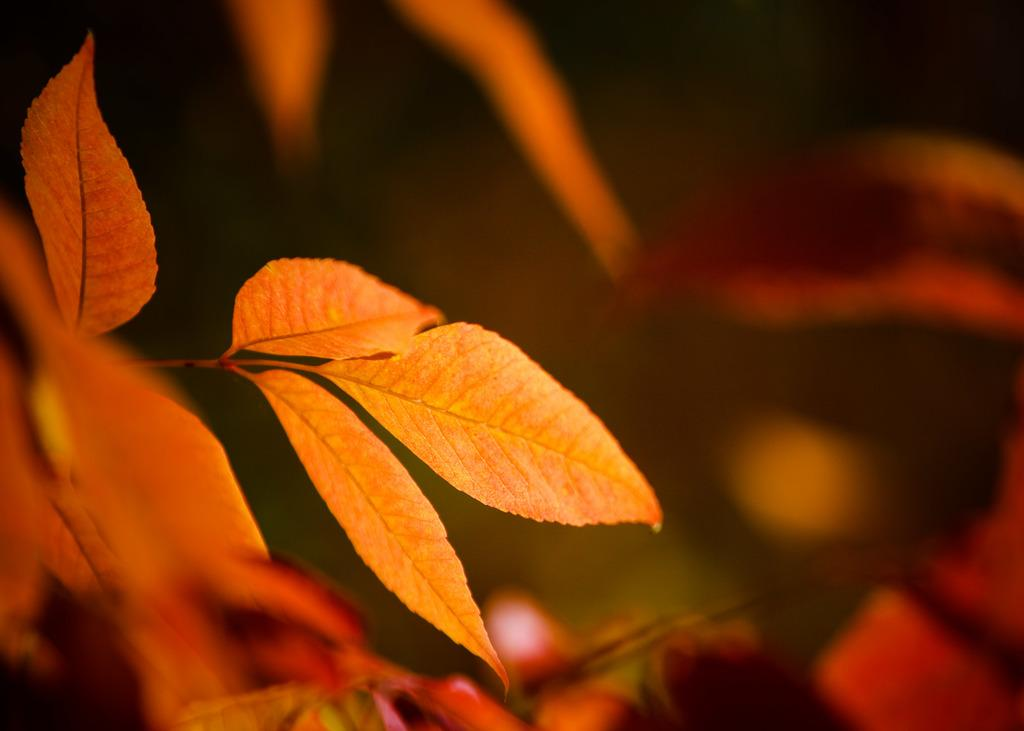What type of vegetation can be seen in the image? There are leaves in the image. Can you describe the background of the image? The background of the image is blurred. What type of silver material is present in the image? There is no silver material present in the image; it only features leaves and a blurred background. 